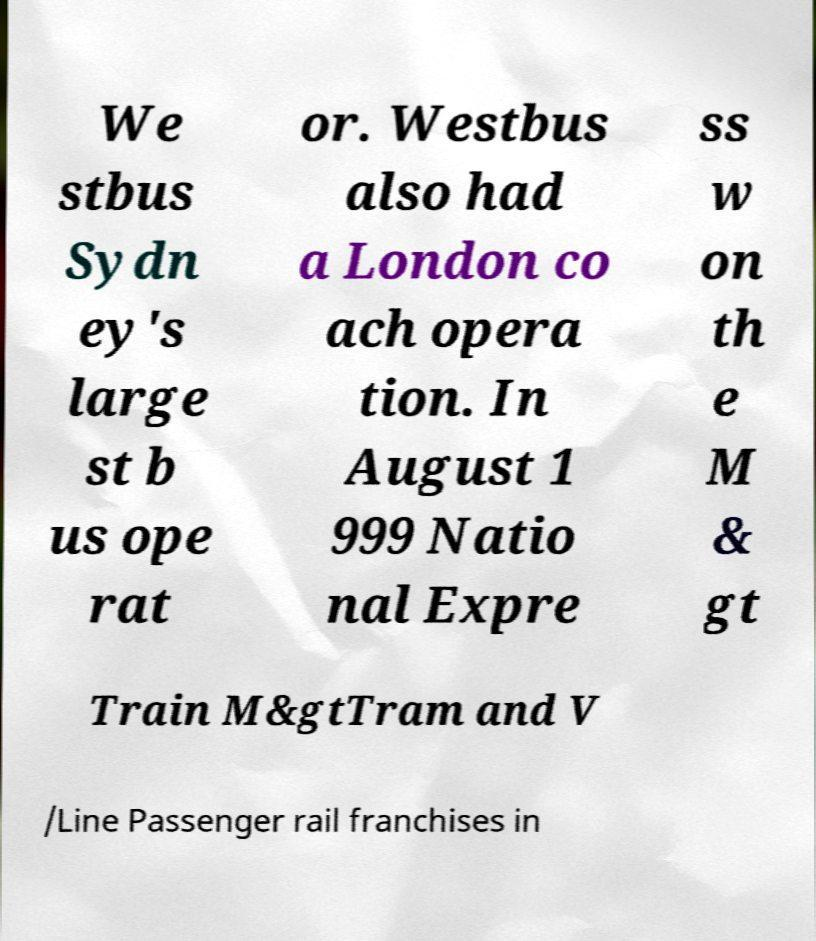I need the written content from this picture converted into text. Can you do that? We stbus Sydn ey's large st b us ope rat or. Westbus also had a London co ach opera tion. In August 1 999 Natio nal Expre ss w on th e M & gt Train M&gtTram and V /Line Passenger rail franchises in 